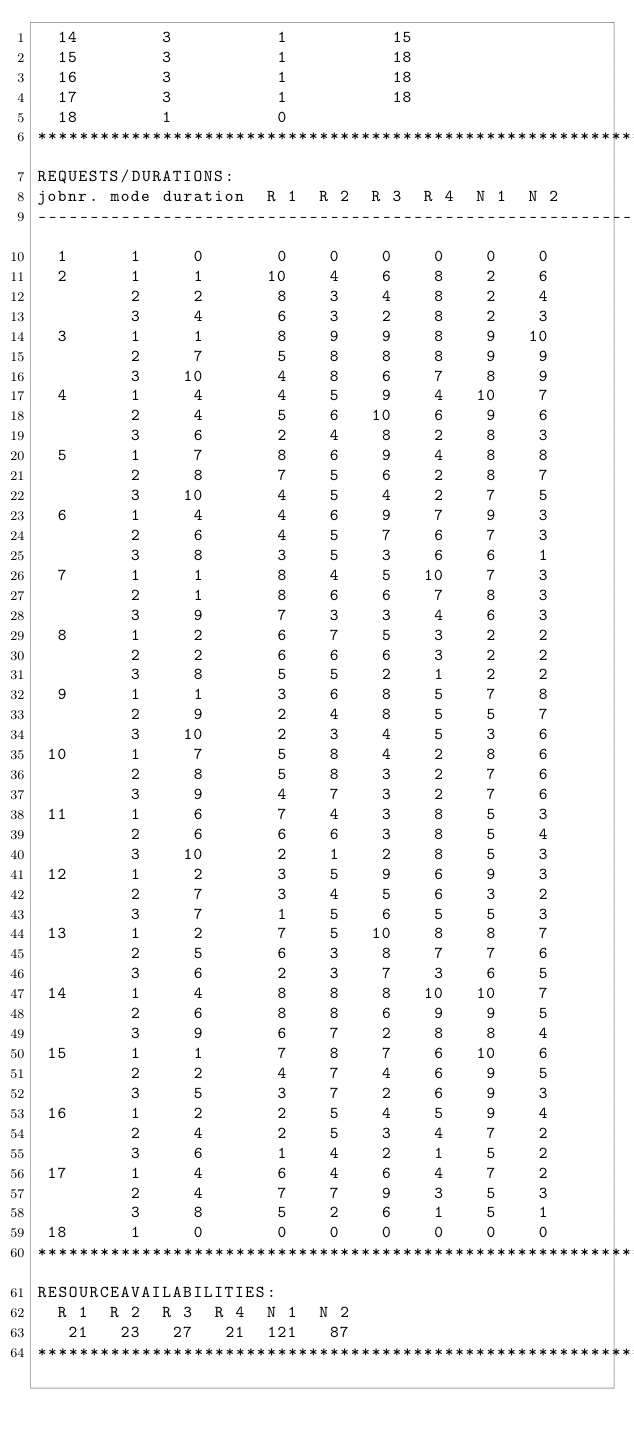<code> <loc_0><loc_0><loc_500><loc_500><_ObjectiveC_>  14        3          1          15
  15        3          1          18
  16        3          1          18
  17        3          1          18
  18        1          0        
************************************************************************
REQUESTS/DURATIONS:
jobnr. mode duration  R 1  R 2  R 3  R 4  N 1  N 2
------------------------------------------------------------------------
  1      1     0       0    0    0    0    0    0
  2      1     1      10    4    6    8    2    6
         2     2       8    3    4    8    2    4
         3     4       6    3    2    8    2    3
  3      1     1       8    9    9    8    9   10
         2     7       5    8    8    8    9    9
         3    10       4    8    6    7    8    9
  4      1     4       4    5    9    4   10    7
         2     4       5    6   10    6    9    6
         3     6       2    4    8    2    8    3
  5      1     7       8    6    9    4    8    8
         2     8       7    5    6    2    8    7
         3    10       4    5    4    2    7    5
  6      1     4       4    6    9    7    9    3
         2     6       4    5    7    6    7    3
         3     8       3    5    3    6    6    1
  7      1     1       8    4    5   10    7    3
         2     1       8    6    6    7    8    3
         3     9       7    3    3    4    6    3
  8      1     2       6    7    5    3    2    2
         2     2       6    6    6    3    2    2
         3     8       5    5    2    1    2    2
  9      1     1       3    6    8    5    7    8
         2     9       2    4    8    5    5    7
         3    10       2    3    4    5    3    6
 10      1     7       5    8    4    2    8    6
         2     8       5    8    3    2    7    6
         3     9       4    7    3    2    7    6
 11      1     6       7    4    3    8    5    3
         2     6       6    6    3    8    5    4
         3    10       2    1    2    8    5    3
 12      1     2       3    5    9    6    9    3
         2     7       3    4    5    6    3    2
         3     7       1    5    6    5    5    3
 13      1     2       7    5   10    8    8    7
         2     5       6    3    8    7    7    6
         3     6       2    3    7    3    6    5
 14      1     4       8    8    8   10   10    7
         2     6       8    8    6    9    9    5
         3     9       6    7    2    8    8    4
 15      1     1       7    8    7    6   10    6
         2     2       4    7    4    6    9    5
         3     5       3    7    2    6    9    3
 16      1     2       2    5    4    5    9    4
         2     4       2    5    3    4    7    2
         3     6       1    4    2    1    5    2
 17      1     4       6    4    6    4    7    2
         2     4       7    7    9    3    5    3
         3     8       5    2    6    1    5    1
 18      1     0       0    0    0    0    0    0
************************************************************************
RESOURCEAVAILABILITIES:
  R 1  R 2  R 3  R 4  N 1  N 2
   21   23   27   21  121   87
************************************************************************
</code> 